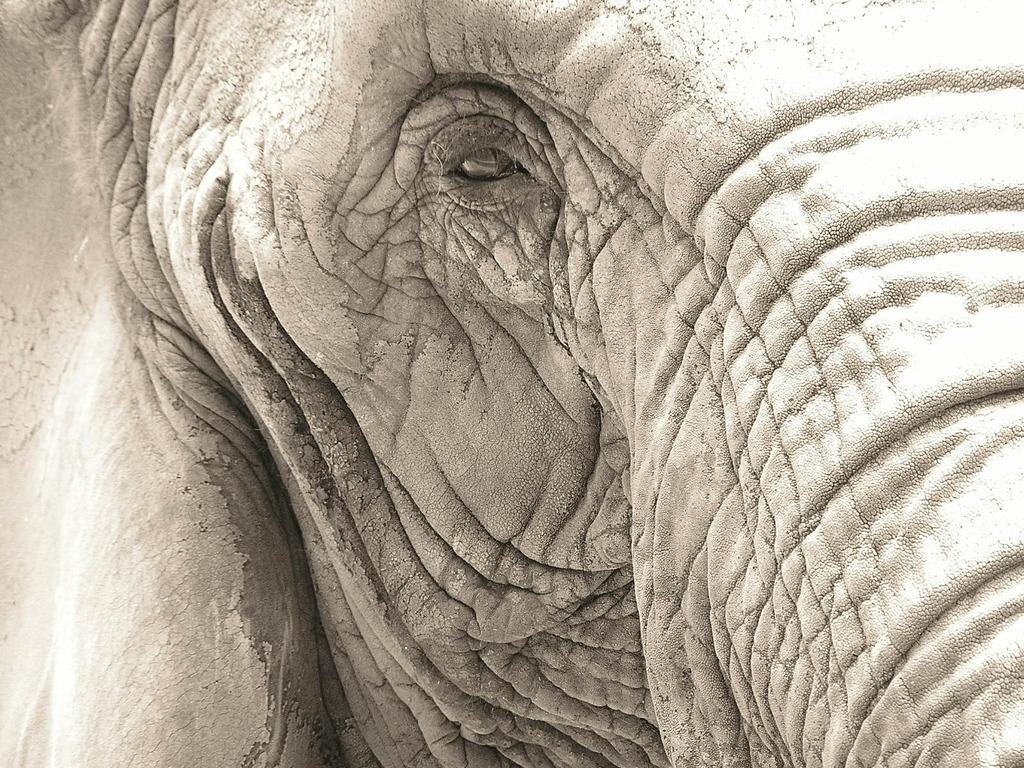What animal is the main subject of the image? There is an elephant in the image. Can you describe the time of day when the image was taken? The image appears to be taken during the day. What type of ornament is hanging from the elephant's ear in the image? There is no ornament hanging from the elephant's ear in the image. How many rabbits can be seen playing with the elephant in the image? There are no rabbits present in the image; it features an elephant. 